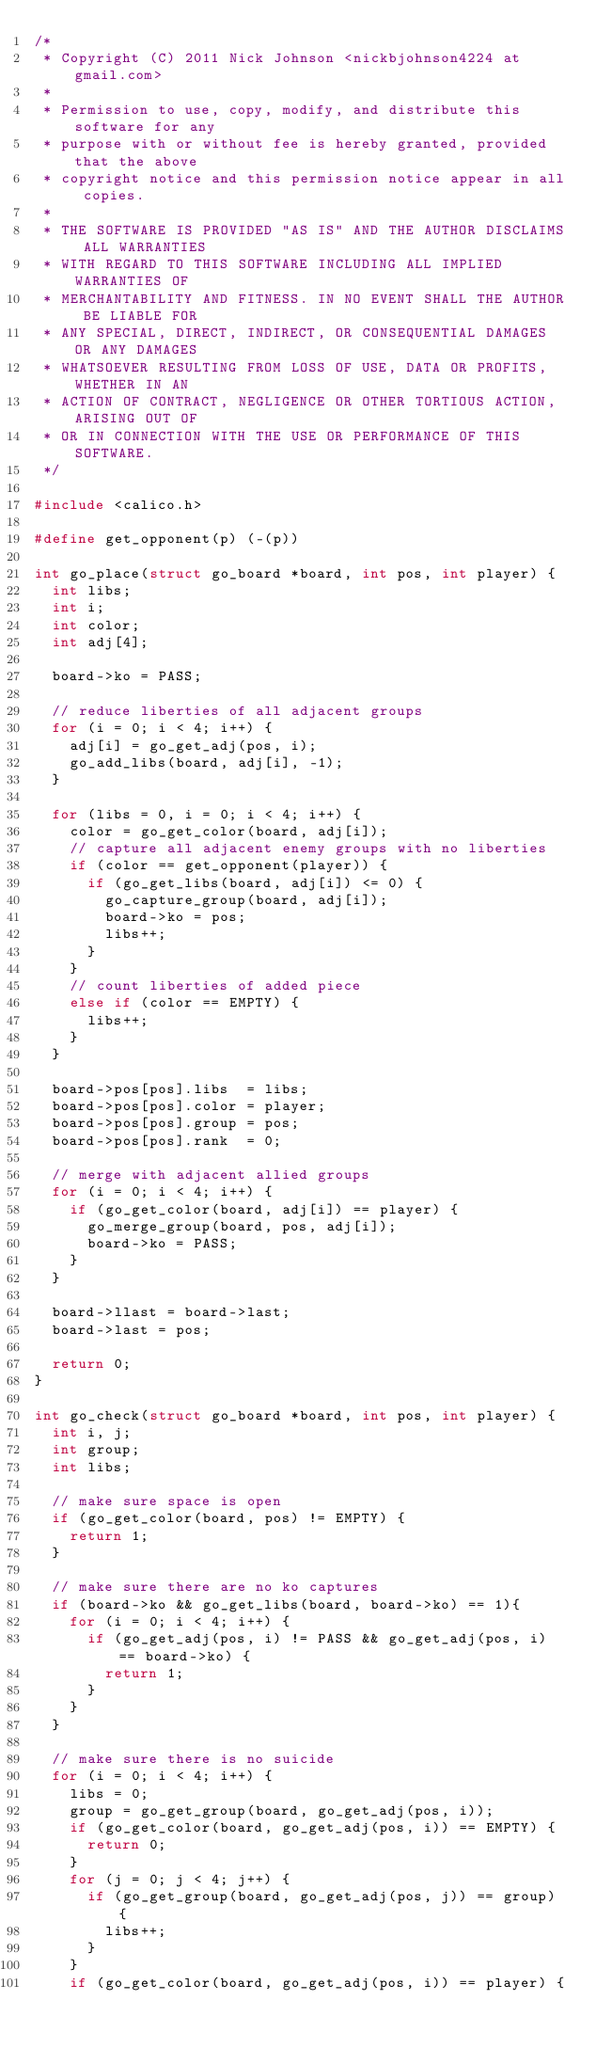Convert code to text. <code><loc_0><loc_0><loc_500><loc_500><_C_>/*
 * Copyright (C) 2011 Nick Johnson <nickbjohnson4224 at gmail.com>
 * 
 * Permission to use, copy, modify, and distribute this software for any
 * purpose with or without fee is hereby granted, provided that the above
 * copyright notice and this permission notice appear in all copies.
 *
 * THE SOFTWARE IS PROVIDED "AS IS" AND THE AUTHOR DISCLAIMS ALL WARRANTIES
 * WITH REGARD TO THIS SOFTWARE INCLUDING ALL IMPLIED WARRANTIES OF
 * MERCHANTABILITY AND FITNESS. IN NO EVENT SHALL THE AUTHOR BE LIABLE FOR
 * ANY SPECIAL, DIRECT, INDIRECT, OR CONSEQUENTIAL DAMAGES OR ANY DAMAGES
 * WHATSOEVER RESULTING FROM LOSS OF USE, DATA OR PROFITS, WHETHER IN AN
 * ACTION OF CONTRACT, NEGLIGENCE OR OTHER TORTIOUS ACTION, ARISING OUT OF
 * OR IN CONNECTION WITH THE USE OR PERFORMANCE OF THIS SOFTWARE.
 */

#include <calico.h>

#define get_opponent(p) (-(p))

int go_place(struct go_board *board, int pos, int player) {
	int libs;
	int i;
	int color;
	int adj[4];
	
	board->ko = PASS;

	// reduce liberties of all adjacent groups
	for (i = 0; i < 4; i++) {
		adj[i] = go_get_adj(pos, i);
		go_add_libs(board, adj[i], -1);
	}

	for (libs = 0, i = 0; i < 4; i++) {
		color = go_get_color(board, adj[i]);
		// capture all adjacent enemy groups with no liberties
		if (color == get_opponent(player)) {
			if (go_get_libs(board, adj[i]) <= 0) {
				go_capture_group(board, adj[i]);
				board->ko = pos;
				libs++;
			}
		}
		// count liberties of added piece
		else if (color == EMPTY) {
			libs++;
		}
	}

	board->pos[pos].libs  = libs;
	board->pos[pos].color = player;
	board->pos[pos].group = pos;
	board->pos[pos].rank  = 0;

	// merge with adjacent allied groups
	for (i = 0; i < 4; i++) {
		if (go_get_color(board, adj[i]) == player) {
			go_merge_group(board, pos, adj[i]);
			board->ko = PASS;
		}
	}

	board->llast = board->last;
	board->last = pos;

	return 0;
}

int go_check(struct go_board *board, int pos, int player) {
	int i, j;
	int group;
	int libs;

	// make sure space is open
	if (go_get_color(board, pos) != EMPTY) {
		return 1;
	}
	
	// make sure there are no ko captures
	if (board->ko && go_get_libs(board, board->ko) == 1){
		for (i = 0; i < 4; i++) {
			if (go_get_adj(pos, i) != PASS && go_get_adj(pos, i) == board->ko) {
				return 1;
			}
		}
	}

	// make sure there is no suicide
	for (i = 0; i < 4; i++) {
		libs = 0;
		group = go_get_group(board, go_get_adj(pos, i));
		if (go_get_color(board, go_get_adj(pos, i)) == EMPTY) {
			return 0;
		}
		for (j = 0; j < 4; j++) {
			if (go_get_group(board, go_get_adj(pos, j)) == group) {
				libs++;
			}
		}
		if (go_get_color(board, go_get_adj(pos, i)) == player) {</code> 